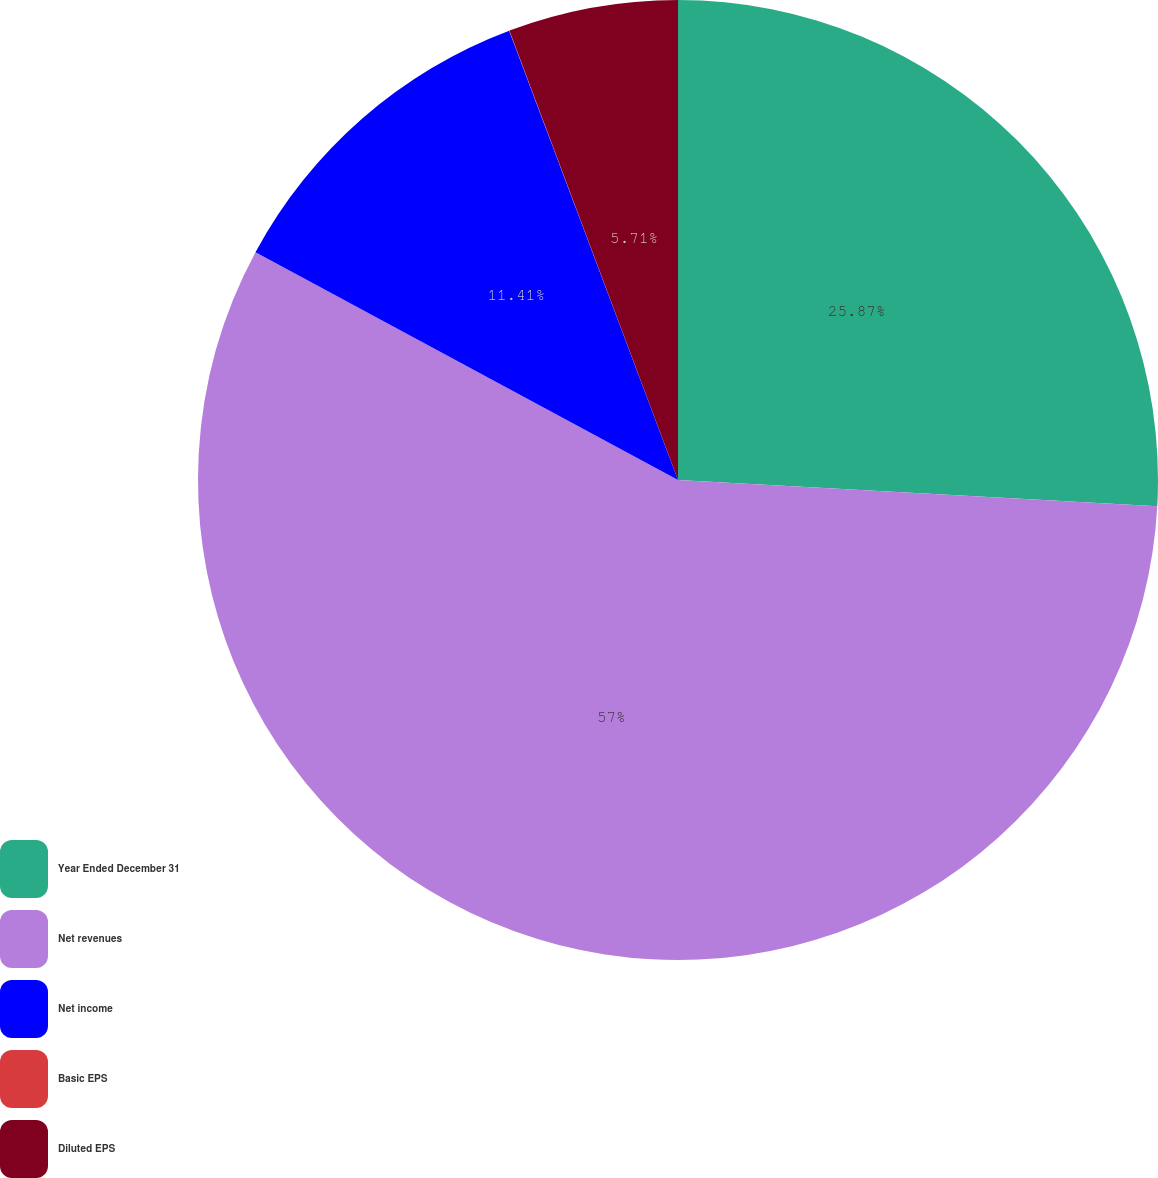Convert chart. <chart><loc_0><loc_0><loc_500><loc_500><pie_chart><fcel>Year Ended December 31<fcel>Net revenues<fcel>Net income<fcel>Basic EPS<fcel>Diluted EPS<nl><fcel>25.87%<fcel>57.0%<fcel>11.41%<fcel>0.01%<fcel>5.71%<nl></chart> 